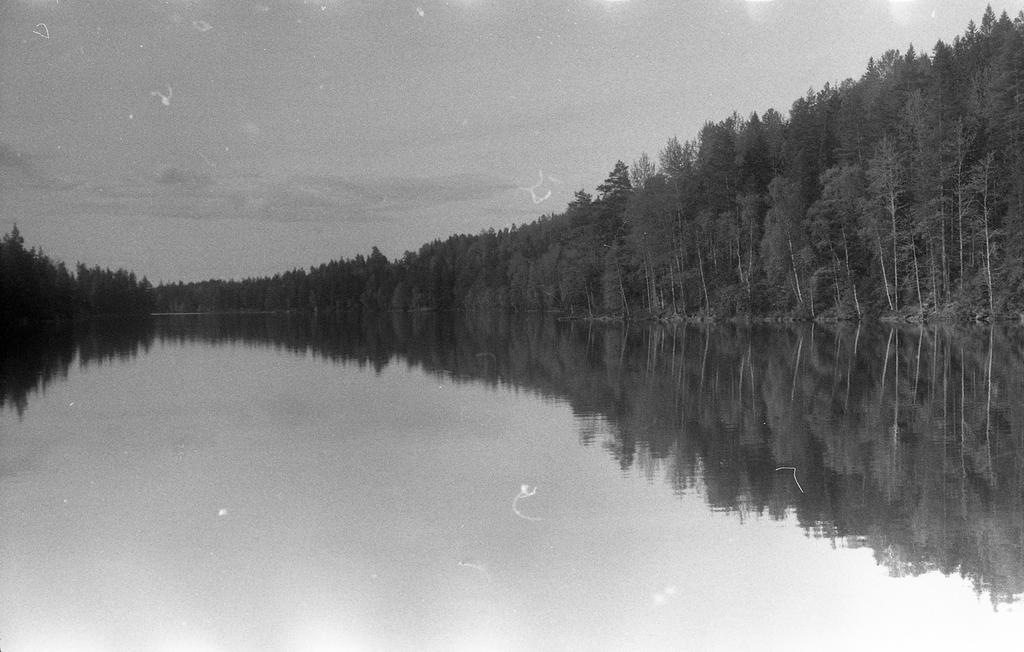How would you summarize this image in a sentence or two? In this picture we can see water and trees and we can see sky in the background. 